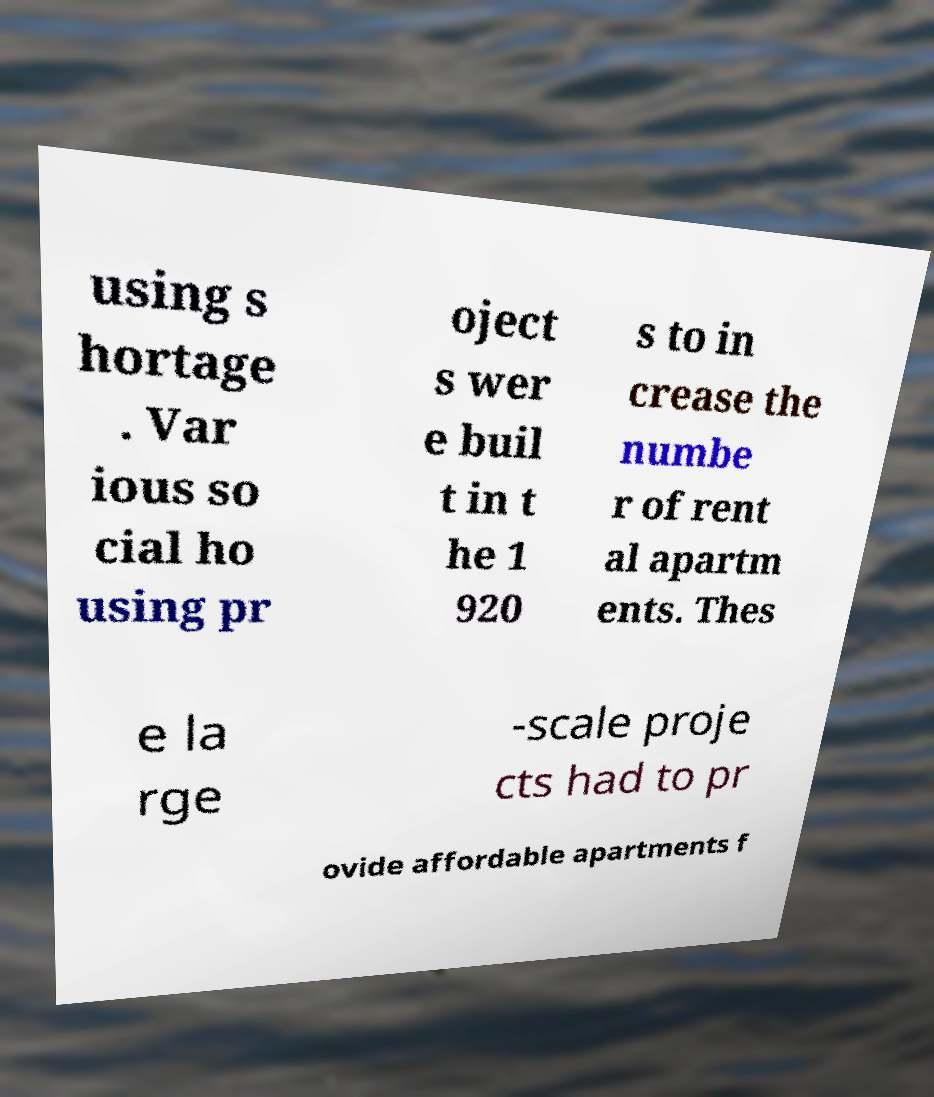What messages or text are displayed in this image? I need them in a readable, typed format. using s hortage . Var ious so cial ho using pr oject s wer e buil t in t he 1 920 s to in crease the numbe r of rent al apartm ents. Thes e la rge -scale proje cts had to pr ovide affordable apartments f 